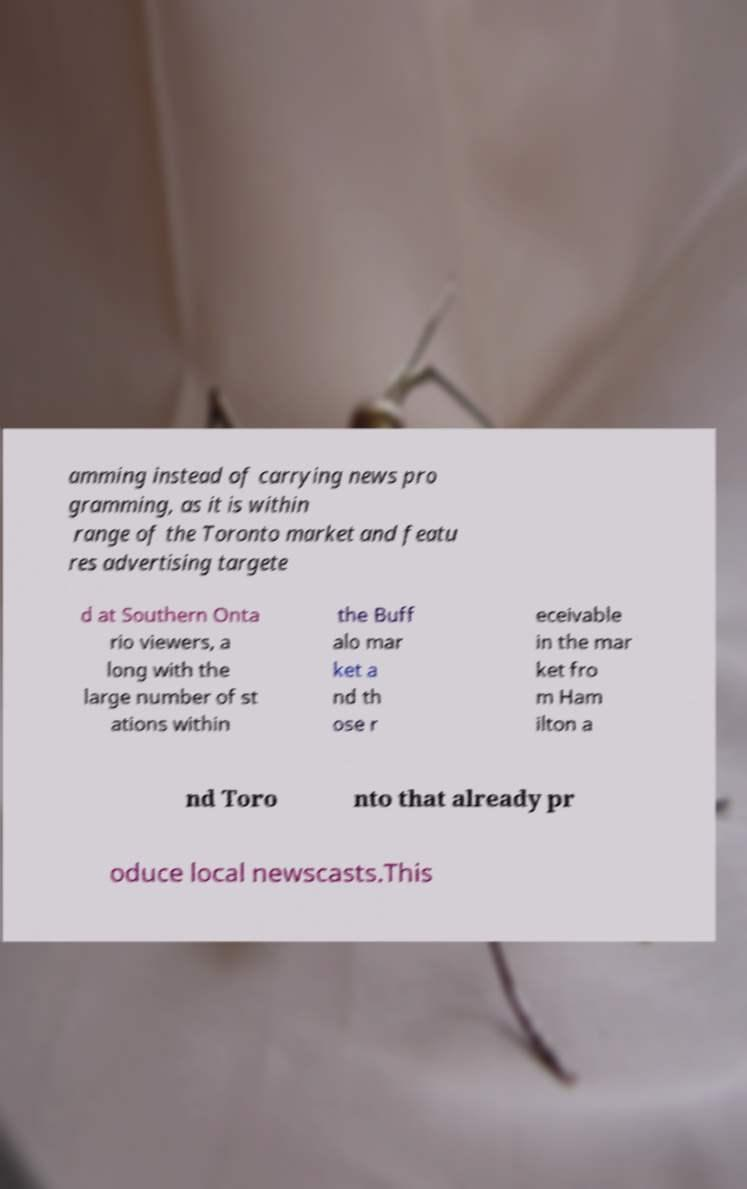Can you read and provide the text displayed in the image?This photo seems to have some interesting text. Can you extract and type it out for me? amming instead of carrying news pro gramming, as it is within range of the Toronto market and featu res advertising targete d at Southern Onta rio viewers, a long with the large number of st ations within the Buff alo mar ket a nd th ose r eceivable in the mar ket fro m Ham ilton a nd Toro nto that already pr oduce local newscasts.This 